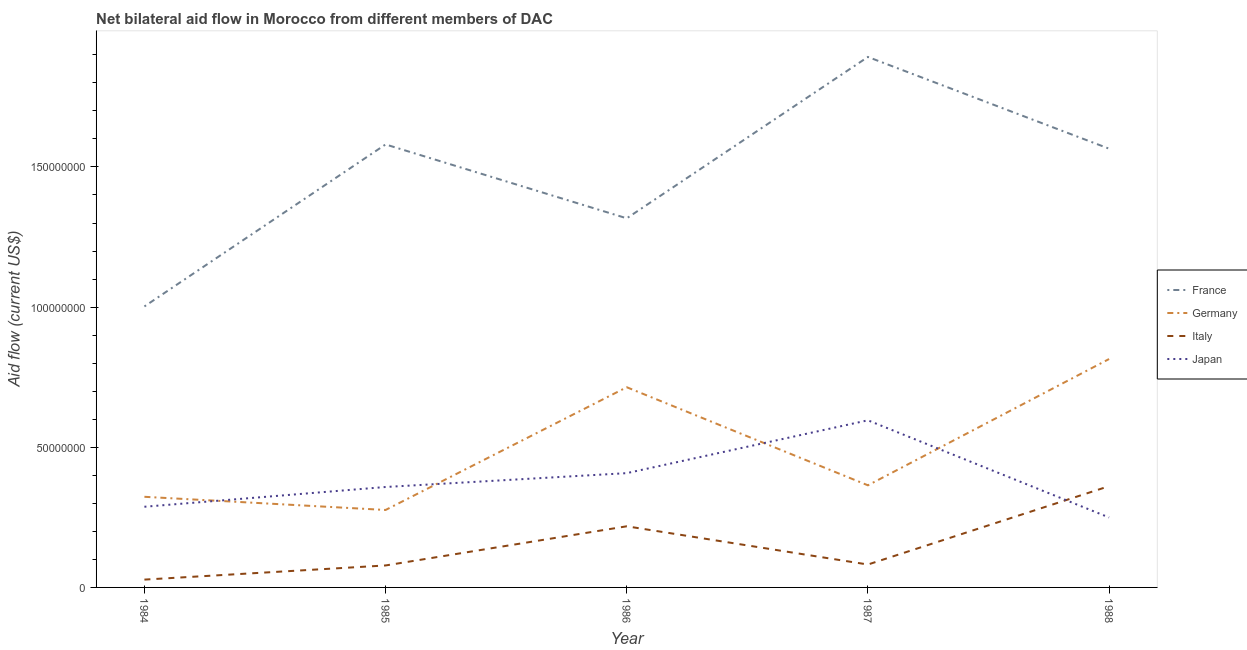Does the line corresponding to amount of aid given by germany intersect with the line corresponding to amount of aid given by italy?
Keep it short and to the point. No. What is the amount of aid given by france in 1986?
Offer a very short reply. 1.32e+08. Across all years, what is the maximum amount of aid given by japan?
Ensure brevity in your answer.  5.96e+07. Across all years, what is the minimum amount of aid given by japan?
Provide a short and direct response. 2.50e+07. In which year was the amount of aid given by germany minimum?
Give a very brief answer. 1985. What is the total amount of aid given by germany in the graph?
Offer a terse response. 2.49e+08. What is the difference between the amount of aid given by france in 1986 and that in 1988?
Offer a terse response. -2.48e+07. What is the difference between the amount of aid given by italy in 1988 and the amount of aid given by germany in 1985?
Your answer should be very brief. 8.50e+06. What is the average amount of aid given by germany per year?
Offer a very short reply. 4.99e+07. In the year 1987, what is the difference between the amount of aid given by france and amount of aid given by germany?
Offer a very short reply. 1.53e+08. What is the ratio of the amount of aid given by germany in 1984 to that in 1986?
Your response must be concise. 0.45. Is the amount of aid given by germany in 1987 less than that in 1988?
Offer a very short reply. Yes. Is the difference between the amount of aid given by france in 1984 and 1986 greater than the difference between the amount of aid given by japan in 1984 and 1986?
Give a very brief answer. No. What is the difference between the highest and the second highest amount of aid given by france?
Give a very brief answer. 3.12e+07. What is the difference between the highest and the lowest amount of aid given by france?
Make the answer very short. 8.90e+07. In how many years, is the amount of aid given by japan greater than the average amount of aid given by japan taken over all years?
Offer a terse response. 2. Is the sum of the amount of aid given by france in 1984 and 1986 greater than the maximum amount of aid given by italy across all years?
Offer a very short reply. Yes. Is it the case that in every year, the sum of the amount of aid given by italy and amount of aid given by japan is greater than the sum of amount of aid given by germany and amount of aid given by france?
Offer a terse response. No. Does the amount of aid given by italy monotonically increase over the years?
Offer a very short reply. No. Is the amount of aid given by japan strictly less than the amount of aid given by france over the years?
Offer a very short reply. Yes. Are the values on the major ticks of Y-axis written in scientific E-notation?
Keep it short and to the point. No. Does the graph contain any zero values?
Give a very brief answer. No. Does the graph contain grids?
Provide a short and direct response. No. How many legend labels are there?
Offer a very short reply. 4. What is the title of the graph?
Your answer should be compact. Net bilateral aid flow in Morocco from different members of DAC. Does "Primary schools" appear as one of the legend labels in the graph?
Give a very brief answer. No. What is the label or title of the Y-axis?
Make the answer very short. Aid flow (current US$). What is the Aid flow (current US$) of France in 1984?
Provide a short and direct response. 1.00e+08. What is the Aid flow (current US$) of Germany in 1984?
Your answer should be very brief. 3.23e+07. What is the Aid flow (current US$) of Italy in 1984?
Give a very brief answer. 2.79e+06. What is the Aid flow (current US$) of Japan in 1984?
Offer a terse response. 2.88e+07. What is the Aid flow (current US$) of France in 1985?
Your answer should be very brief. 1.58e+08. What is the Aid flow (current US$) in Germany in 1985?
Your answer should be very brief. 2.76e+07. What is the Aid flow (current US$) of Italy in 1985?
Make the answer very short. 7.84e+06. What is the Aid flow (current US$) in Japan in 1985?
Offer a very short reply. 3.58e+07. What is the Aid flow (current US$) in France in 1986?
Keep it short and to the point. 1.32e+08. What is the Aid flow (current US$) in Germany in 1986?
Your answer should be compact. 7.14e+07. What is the Aid flow (current US$) of Italy in 1986?
Your answer should be compact. 2.18e+07. What is the Aid flow (current US$) of Japan in 1986?
Your answer should be very brief. 4.08e+07. What is the Aid flow (current US$) of France in 1987?
Your response must be concise. 1.89e+08. What is the Aid flow (current US$) in Germany in 1987?
Ensure brevity in your answer.  3.64e+07. What is the Aid flow (current US$) of Italy in 1987?
Give a very brief answer. 8.17e+06. What is the Aid flow (current US$) in Japan in 1987?
Make the answer very short. 5.96e+07. What is the Aid flow (current US$) in France in 1988?
Offer a terse response. 1.57e+08. What is the Aid flow (current US$) in Germany in 1988?
Make the answer very short. 8.15e+07. What is the Aid flow (current US$) in Italy in 1988?
Provide a short and direct response. 3.61e+07. What is the Aid flow (current US$) of Japan in 1988?
Your response must be concise. 2.50e+07. Across all years, what is the maximum Aid flow (current US$) of France?
Ensure brevity in your answer.  1.89e+08. Across all years, what is the maximum Aid flow (current US$) in Germany?
Your answer should be very brief. 8.15e+07. Across all years, what is the maximum Aid flow (current US$) in Italy?
Your answer should be compact. 3.61e+07. Across all years, what is the maximum Aid flow (current US$) of Japan?
Your answer should be compact. 5.96e+07. Across all years, what is the minimum Aid flow (current US$) of France?
Provide a short and direct response. 1.00e+08. Across all years, what is the minimum Aid flow (current US$) in Germany?
Provide a short and direct response. 2.76e+07. Across all years, what is the minimum Aid flow (current US$) in Italy?
Give a very brief answer. 2.79e+06. Across all years, what is the minimum Aid flow (current US$) of Japan?
Provide a short and direct response. 2.50e+07. What is the total Aid flow (current US$) in France in the graph?
Keep it short and to the point. 7.36e+08. What is the total Aid flow (current US$) of Germany in the graph?
Offer a terse response. 2.49e+08. What is the total Aid flow (current US$) of Italy in the graph?
Keep it short and to the point. 7.67e+07. What is the total Aid flow (current US$) of Japan in the graph?
Offer a very short reply. 1.90e+08. What is the difference between the Aid flow (current US$) in France in 1984 and that in 1985?
Ensure brevity in your answer.  -5.78e+07. What is the difference between the Aid flow (current US$) of Germany in 1984 and that in 1985?
Ensure brevity in your answer.  4.70e+06. What is the difference between the Aid flow (current US$) in Italy in 1984 and that in 1985?
Your answer should be very brief. -5.05e+06. What is the difference between the Aid flow (current US$) in Japan in 1984 and that in 1985?
Keep it short and to the point. -7.05e+06. What is the difference between the Aid flow (current US$) of France in 1984 and that in 1986?
Keep it short and to the point. -3.14e+07. What is the difference between the Aid flow (current US$) of Germany in 1984 and that in 1986?
Keep it short and to the point. -3.91e+07. What is the difference between the Aid flow (current US$) of Italy in 1984 and that in 1986?
Your response must be concise. -1.90e+07. What is the difference between the Aid flow (current US$) of Japan in 1984 and that in 1986?
Offer a very short reply. -1.20e+07. What is the difference between the Aid flow (current US$) in France in 1984 and that in 1987?
Your answer should be very brief. -8.90e+07. What is the difference between the Aid flow (current US$) of Germany in 1984 and that in 1987?
Your answer should be very brief. -4.10e+06. What is the difference between the Aid flow (current US$) of Italy in 1984 and that in 1987?
Ensure brevity in your answer.  -5.38e+06. What is the difference between the Aid flow (current US$) of Japan in 1984 and that in 1987?
Offer a very short reply. -3.08e+07. What is the difference between the Aid flow (current US$) of France in 1984 and that in 1988?
Your answer should be very brief. -5.63e+07. What is the difference between the Aid flow (current US$) of Germany in 1984 and that in 1988?
Make the answer very short. -4.92e+07. What is the difference between the Aid flow (current US$) in Italy in 1984 and that in 1988?
Your response must be concise. -3.33e+07. What is the difference between the Aid flow (current US$) of Japan in 1984 and that in 1988?
Provide a short and direct response. 3.83e+06. What is the difference between the Aid flow (current US$) of France in 1985 and that in 1986?
Make the answer very short. 2.64e+07. What is the difference between the Aid flow (current US$) in Germany in 1985 and that in 1986?
Keep it short and to the point. -4.38e+07. What is the difference between the Aid flow (current US$) of Italy in 1985 and that in 1986?
Ensure brevity in your answer.  -1.40e+07. What is the difference between the Aid flow (current US$) in Japan in 1985 and that in 1986?
Ensure brevity in your answer.  -4.94e+06. What is the difference between the Aid flow (current US$) of France in 1985 and that in 1987?
Offer a terse response. -3.12e+07. What is the difference between the Aid flow (current US$) in Germany in 1985 and that in 1987?
Your answer should be very brief. -8.80e+06. What is the difference between the Aid flow (current US$) in Italy in 1985 and that in 1987?
Offer a terse response. -3.30e+05. What is the difference between the Aid flow (current US$) of Japan in 1985 and that in 1987?
Your answer should be compact. -2.38e+07. What is the difference between the Aid flow (current US$) in France in 1985 and that in 1988?
Provide a succinct answer. 1.51e+06. What is the difference between the Aid flow (current US$) in Germany in 1985 and that in 1988?
Keep it short and to the point. -5.38e+07. What is the difference between the Aid flow (current US$) of Italy in 1985 and that in 1988?
Give a very brief answer. -2.83e+07. What is the difference between the Aid flow (current US$) of Japan in 1985 and that in 1988?
Provide a succinct answer. 1.09e+07. What is the difference between the Aid flow (current US$) in France in 1986 and that in 1987?
Your answer should be compact. -5.76e+07. What is the difference between the Aid flow (current US$) of Germany in 1986 and that in 1987?
Give a very brief answer. 3.50e+07. What is the difference between the Aid flow (current US$) in Italy in 1986 and that in 1987?
Your answer should be very brief. 1.36e+07. What is the difference between the Aid flow (current US$) in Japan in 1986 and that in 1987?
Your answer should be very brief. -1.88e+07. What is the difference between the Aid flow (current US$) in France in 1986 and that in 1988?
Your answer should be compact. -2.48e+07. What is the difference between the Aid flow (current US$) in Germany in 1986 and that in 1988?
Give a very brief answer. -1.01e+07. What is the difference between the Aid flow (current US$) in Italy in 1986 and that in 1988?
Offer a very short reply. -1.43e+07. What is the difference between the Aid flow (current US$) in Japan in 1986 and that in 1988?
Your answer should be compact. 1.58e+07. What is the difference between the Aid flow (current US$) in France in 1987 and that in 1988?
Make the answer very short. 3.27e+07. What is the difference between the Aid flow (current US$) of Germany in 1987 and that in 1988?
Give a very brief answer. -4.50e+07. What is the difference between the Aid flow (current US$) of Italy in 1987 and that in 1988?
Give a very brief answer. -2.80e+07. What is the difference between the Aid flow (current US$) of Japan in 1987 and that in 1988?
Your answer should be compact. 3.47e+07. What is the difference between the Aid flow (current US$) in France in 1984 and the Aid flow (current US$) in Germany in 1985?
Give a very brief answer. 7.26e+07. What is the difference between the Aid flow (current US$) of France in 1984 and the Aid flow (current US$) of Italy in 1985?
Your response must be concise. 9.24e+07. What is the difference between the Aid flow (current US$) of France in 1984 and the Aid flow (current US$) of Japan in 1985?
Your response must be concise. 6.44e+07. What is the difference between the Aid flow (current US$) in Germany in 1984 and the Aid flow (current US$) in Italy in 1985?
Provide a short and direct response. 2.45e+07. What is the difference between the Aid flow (current US$) of Germany in 1984 and the Aid flow (current US$) of Japan in 1985?
Offer a very short reply. -3.50e+06. What is the difference between the Aid flow (current US$) of Italy in 1984 and the Aid flow (current US$) of Japan in 1985?
Ensure brevity in your answer.  -3.30e+07. What is the difference between the Aid flow (current US$) of France in 1984 and the Aid flow (current US$) of Germany in 1986?
Provide a succinct answer. 2.88e+07. What is the difference between the Aid flow (current US$) in France in 1984 and the Aid flow (current US$) in Italy in 1986?
Offer a terse response. 7.84e+07. What is the difference between the Aid flow (current US$) in France in 1984 and the Aid flow (current US$) in Japan in 1986?
Your answer should be very brief. 5.95e+07. What is the difference between the Aid flow (current US$) in Germany in 1984 and the Aid flow (current US$) in Italy in 1986?
Ensure brevity in your answer.  1.05e+07. What is the difference between the Aid flow (current US$) in Germany in 1984 and the Aid flow (current US$) in Japan in 1986?
Provide a short and direct response. -8.44e+06. What is the difference between the Aid flow (current US$) of Italy in 1984 and the Aid flow (current US$) of Japan in 1986?
Make the answer very short. -3.80e+07. What is the difference between the Aid flow (current US$) of France in 1984 and the Aid flow (current US$) of Germany in 1987?
Ensure brevity in your answer.  6.38e+07. What is the difference between the Aid flow (current US$) of France in 1984 and the Aid flow (current US$) of Italy in 1987?
Your response must be concise. 9.21e+07. What is the difference between the Aid flow (current US$) of France in 1984 and the Aid flow (current US$) of Japan in 1987?
Provide a short and direct response. 4.06e+07. What is the difference between the Aid flow (current US$) in Germany in 1984 and the Aid flow (current US$) in Italy in 1987?
Give a very brief answer. 2.42e+07. What is the difference between the Aid flow (current US$) in Germany in 1984 and the Aid flow (current US$) in Japan in 1987?
Your answer should be compact. -2.73e+07. What is the difference between the Aid flow (current US$) in Italy in 1984 and the Aid flow (current US$) in Japan in 1987?
Ensure brevity in your answer.  -5.68e+07. What is the difference between the Aid flow (current US$) of France in 1984 and the Aid flow (current US$) of Germany in 1988?
Make the answer very short. 1.88e+07. What is the difference between the Aid flow (current US$) of France in 1984 and the Aid flow (current US$) of Italy in 1988?
Your answer should be compact. 6.41e+07. What is the difference between the Aid flow (current US$) of France in 1984 and the Aid flow (current US$) of Japan in 1988?
Keep it short and to the point. 7.53e+07. What is the difference between the Aid flow (current US$) in Germany in 1984 and the Aid flow (current US$) in Italy in 1988?
Give a very brief answer. -3.80e+06. What is the difference between the Aid flow (current US$) of Germany in 1984 and the Aid flow (current US$) of Japan in 1988?
Offer a terse response. 7.38e+06. What is the difference between the Aid flow (current US$) of Italy in 1984 and the Aid flow (current US$) of Japan in 1988?
Your answer should be very brief. -2.22e+07. What is the difference between the Aid flow (current US$) of France in 1985 and the Aid flow (current US$) of Germany in 1986?
Ensure brevity in your answer.  8.66e+07. What is the difference between the Aid flow (current US$) in France in 1985 and the Aid flow (current US$) in Italy in 1986?
Provide a short and direct response. 1.36e+08. What is the difference between the Aid flow (current US$) of France in 1985 and the Aid flow (current US$) of Japan in 1986?
Offer a very short reply. 1.17e+08. What is the difference between the Aid flow (current US$) in Germany in 1985 and the Aid flow (current US$) in Italy in 1986?
Keep it short and to the point. 5.82e+06. What is the difference between the Aid flow (current US$) of Germany in 1985 and the Aid flow (current US$) of Japan in 1986?
Your answer should be very brief. -1.31e+07. What is the difference between the Aid flow (current US$) of Italy in 1985 and the Aid flow (current US$) of Japan in 1986?
Offer a terse response. -3.29e+07. What is the difference between the Aid flow (current US$) in France in 1985 and the Aid flow (current US$) in Germany in 1987?
Offer a very short reply. 1.22e+08. What is the difference between the Aid flow (current US$) of France in 1985 and the Aid flow (current US$) of Italy in 1987?
Make the answer very short. 1.50e+08. What is the difference between the Aid flow (current US$) in France in 1985 and the Aid flow (current US$) in Japan in 1987?
Your answer should be very brief. 9.84e+07. What is the difference between the Aid flow (current US$) in Germany in 1985 and the Aid flow (current US$) in Italy in 1987?
Your answer should be compact. 1.95e+07. What is the difference between the Aid flow (current US$) of Germany in 1985 and the Aid flow (current US$) of Japan in 1987?
Keep it short and to the point. -3.20e+07. What is the difference between the Aid flow (current US$) in Italy in 1985 and the Aid flow (current US$) in Japan in 1987?
Ensure brevity in your answer.  -5.18e+07. What is the difference between the Aid flow (current US$) in France in 1985 and the Aid flow (current US$) in Germany in 1988?
Provide a short and direct response. 7.66e+07. What is the difference between the Aid flow (current US$) of France in 1985 and the Aid flow (current US$) of Italy in 1988?
Provide a short and direct response. 1.22e+08. What is the difference between the Aid flow (current US$) of France in 1985 and the Aid flow (current US$) of Japan in 1988?
Your answer should be very brief. 1.33e+08. What is the difference between the Aid flow (current US$) of Germany in 1985 and the Aid flow (current US$) of Italy in 1988?
Keep it short and to the point. -8.50e+06. What is the difference between the Aid flow (current US$) of Germany in 1985 and the Aid flow (current US$) of Japan in 1988?
Make the answer very short. 2.68e+06. What is the difference between the Aid flow (current US$) of Italy in 1985 and the Aid flow (current US$) of Japan in 1988?
Your answer should be very brief. -1.71e+07. What is the difference between the Aid flow (current US$) in France in 1986 and the Aid flow (current US$) in Germany in 1987?
Make the answer very short. 9.52e+07. What is the difference between the Aid flow (current US$) in France in 1986 and the Aid flow (current US$) in Italy in 1987?
Ensure brevity in your answer.  1.24e+08. What is the difference between the Aid flow (current US$) in France in 1986 and the Aid flow (current US$) in Japan in 1987?
Your answer should be compact. 7.21e+07. What is the difference between the Aid flow (current US$) of Germany in 1986 and the Aid flow (current US$) of Italy in 1987?
Offer a very short reply. 6.32e+07. What is the difference between the Aid flow (current US$) of Germany in 1986 and the Aid flow (current US$) of Japan in 1987?
Provide a succinct answer. 1.18e+07. What is the difference between the Aid flow (current US$) in Italy in 1986 and the Aid flow (current US$) in Japan in 1987?
Offer a terse response. -3.78e+07. What is the difference between the Aid flow (current US$) in France in 1986 and the Aid flow (current US$) in Germany in 1988?
Offer a very short reply. 5.02e+07. What is the difference between the Aid flow (current US$) of France in 1986 and the Aid flow (current US$) of Italy in 1988?
Your answer should be compact. 9.56e+07. What is the difference between the Aid flow (current US$) of France in 1986 and the Aid flow (current US$) of Japan in 1988?
Provide a short and direct response. 1.07e+08. What is the difference between the Aid flow (current US$) in Germany in 1986 and the Aid flow (current US$) in Italy in 1988?
Offer a very short reply. 3.53e+07. What is the difference between the Aid flow (current US$) of Germany in 1986 and the Aid flow (current US$) of Japan in 1988?
Provide a succinct answer. 4.65e+07. What is the difference between the Aid flow (current US$) in Italy in 1986 and the Aid flow (current US$) in Japan in 1988?
Keep it short and to the point. -3.14e+06. What is the difference between the Aid flow (current US$) of France in 1987 and the Aid flow (current US$) of Germany in 1988?
Make the answer very short. 1.08e+08. What is the difference between the Aid flow (current US$) in France in 1987 and the Aid flow (current US$) in Italy in 1988?
Offer a very short reply. 1.53e+08. What is the difference between the Aid flow (current US$) of France in 1987 and the Aid flow (current US$) of Japan in 1988?
Your answer should be compact. 1.64e+08. What is the difference between the Aid flow (current US$) of Germany in 1987 and the Aid flow (current US$) of Japan in 1988?
Your answer should be compact. 1.15e+07. What is the difference between the Aid flow (current US$) of Italy in 1987 and the Aid flow (current US$) of Japan in 1988?
Provide a succinct answer. -1.68e+07. What is the average Aid flow (current US$) in France per year?
Your answer should be compact. 1.47e+08. What is the average Aid flow (current US$) of Germany per year?
Your answer should be compact. 4.99e+07. What is the average Aid flow (current US$) in Italy per year?
Offer a very short reply. 1.53e+07. What is the average Aid flow (current US$) in Japan per year?
Provide a succinct answer. 3.80e+07. In the year 1984, what is the difference between the Aid flow (current US$) in France and Aid flow (current US$) in Germany?
Ensure brevity in your answer.  6.79e+07. In the year 1984, what is the difference between the Aid flow (current US$) in France and Aid flow (current US$) in Italy?
Keep it short and to the point. 9.74e+07. In the year 1984, what is the difference between the Aid flow (current US$) in France and Aid flow (current US$) in Japan?
Ensure brevity in your answer.  7.15e+07. In the year 1984, what is the difference between the Aid flow (current US$) of Germany and Aid flow (current US$) of Italy?
Make the answer very short. 2.95e+07. In the year 1984, what is the difference between the Aid flow (current US$) in Germany and Aid flow (current US$) in Japan?
Your answer should be very brief. 3.55e+06. In the year 1984, what is the difference between the Aid flow (current US$) in Italy and Aid flow (current US$) in Japan?
Make the answer very short. -2.60e+07. In the year 1985, what is the difference between the Aid flow (current US$) of France and Aid flow (current US$) of Germany?
Keep it short and to the point. 1.30e+08. In the year 1985, what is the difference between the Aid flow (current US$) of France and Aid flow (current US$) of Italy?
Your response must be concise. 1.50e+08. In the year 1985, what is the difference between the Aid flow (current US$) of France and Aid flow (current US$) of Japan?
Make the answer very short. 1.22e+08. In the year 1985, what is the difference between the Aid flow (current US$) in Germany and Aid flow (current US$) in Italy?
Your response must be concise. 1.98e+07. In the year 1985, what is the difference between the Aid flow (current US$) in Germany and Aid flow (current US$) in Japan?
Offer a very short reply. -8.20e+06. In the year 1985, what is the difference between the Aid flow (current US$) in Italy and Aid flow (current US$) in Japan?
Give a very brief answer. -2.80e+07. In the year 1986, what is the difference between the Aid flow (current US$) in France and Aid flow (current US$) in Germany?
Offer a terse response. 6.03e+07. In the year 1986, what is the difference between the Aid flow (current US$) of France and Aid flow (current US$) of Italy?
Offer a terse response. 1.10e+08. In the year 1986, what is the difference between the Aid flow (current US$) in France and Aid flow (current US$) in Japan?
Offer a terse response. 9.09e+07. In the year 1986, what is the difference between the Aid flow (current US$) in Germany and Aid flow (current US$) in Italy?
Give a very brief answer. 4.96e+07. In the year 1986, what is the difference between the Aid flow (current US$) of Germany and Aid flow (current US$) of Japan?
Give a very brief answer. 3.06e+07. In the year 1986, what is the difference between the Aid flow (current US$) of Italy and Aid flow (current US$) of Japan?
Your answer should be compact. -1.90e+07. In the year 1987, what is the difference between the Aid flow (current US$) in France and Aid flow (current US$) in Germany?
Your answer should be very brief. 1.53e+08. In the year 1987, what is the difference between the Aid flow (current US$) of France and Aid flow (current US$) of Italy?
Make the answer very short. 1.81e+08. In the year 1987, what is the difference between the Aid flow (current US$) of France and Aid flow (current US$) of Japan?
Provide a short and direct response. 1.30e+08. In the year 1987, what is the difference between the Aid flow (current US$) of Germany and Aid flow (current US$) of Italy?
Provide a short and direct response. 2.83e+07. In the year 1987, what is the difference between the Aid flow (current US$) in Germany and Aid flow (current US$) in Japan?
Provide a short and direct response. -2.32e+07. In the year 1987, what is the difference between the Aid flow (current US$) of Italy and Aid flow (current US$) of Japan?
Ensure brevity in your answer.  -5.14e+07. In the year 1988, what is the difference between the Aid flow (current US$) of France and Aid flow (current US$) of Germany?
Your response must be concise. 7.50e+07. In the year 1988, what is the difference between the Aid flow (current US$) in France and Aid flow (current US$) in Italy?
Your answer should be compact. 1.20e+08. In the year 1988, what is the difference between the Aid flow (current US$) in France and Aid flow (current US$) in Japan?
Make the answer very short. 1.32e+08. In the year 1988, what is the difference between the Aid flow (current US$) in Germany and Aid flow (current US$) in Italy?
Keep it short and to the point. 4.54e+07. In the year 1988, what is the difference between the Aid flow (current US$) in Germany and Aid flow (current US$) in Japan?
Your response must be concise. 5.65e+07. In the year 1988, what is the difference between the Aid flow (current US$) of Italy and Aid flow (current US$) of Japan?
Make the answer very short. 1.12e+07. What is the ratio of the Aid flow (current US$) in France in 1984 to that in 1985?
Provide a short and direct response. 0.63. What is the ratio of the Aid flow (current US$) in Germany in 1984 to that in 1985?
Keep it short and to the point. 1.17. What is the ratio of the Aid flow (current US$) of Italy in 1984 to that in 1985?
Make the answer very short. 0.36. What is the ratio of the Aid flow (current US$) in Japan in 1984 to that in 1985?
Your answer should be compact. 0.8. What is the ratio of the Aid flow (current US$) in France in 1984 to that in 1986?
Your answer should be very brief. 0.76. What is the ratio of the Aid flow (current US$) of Germany in 1984 to that in 1986?
Make the answer very short. 0.45. What is the ratio of the Aid flow (current US$) of Italy in 1984 to that in 1986?
Your response must be concise. 0.13. What is the ratio of the Aid flow (current US$) in Japan in 1984 to that in 1986?
Make the answer very short. 0.71. What is the ratio of the Aid flow (current US$) of France in 1984 to that in 1987?
Your response must be concise. 0.53. What is the ratio of the Aid flow (current US$) in Germany in 1984 to that in 1987?
Your response must be concise. 0.89. What is the ratio of the Aid flow (current US$) in Italy in 1984 to that in 1987?
Provide a succinct answer. 0.34. What is the ratio of the Aid flow (current US$) in Japan in 1984 to that in 1987?
Keep it short and to the point. 0.48. What is the ratio of the Aid flow (current US$) of France in 1984 to that in 1988?
Your answer should be very brief. 0.64. What is the ratio of the Aid flow (current US$) of Germany in 1984 to that in 1988?
Ensure brevity in your answer.  0.4. What is the ratio of the Aid flow (current US$) in Italy in 1984 to that in 1988?
Your response must be concise. 0.08. What is the ratio of the Aid flow (current US$) in Japan in 1984 to that in 1988?
Ensure brevity in your answer.  1.15. What is the ratio of the Aid flow (current US$) of France in 1985 to that in 1986?
Your answer should be very brief. 1.2. What is the ratio of the Aid flow (current US$) in Germany in 1985 to that in 1986?
Offer a terse response. 0.39. What is the ratio of the Aid flow (current US$) in Italy in 1985 to that in 1986?
Provide a succinct answer. 0.36. What is the ratio of the Aid flow (current US$) in Japan in 1985 to that in 1986?
Offer a terse response. 0.88. What is the ratio of the Aid flow (current US$) in France in 1985 to that in 1987?
Your answer should be very brief. 0.84. What is the ratio of the Aid flow (current US$) of Germany in 1985 to that in 1987?
Provide a succinct answer. 0.76. What is the ratio of the Aid flow (current US$) of Italy in 1985 to that in 1987?
Your answer should be compact. 0.96. What is the ratio of the Aid flow (current US$) of Japan in 1985 to that in 1987?
Ensure brevity in your answer.  0.6. What is the ratio of the Aid flow (current US$) of France in 1985 to that in 1988?
Provide a short and direct response. 1.01. What is the ratio of the Aid flow (current US$) of Germany in 1985 to that in 1988?
Ensure brevity in your answer.  0.34. What is the ratio of the Aid flow (current US$) of Italy in 1985 to that in 1988?
Provide a short and direct response. 0.22. What is the ratio of the Aid flow (current US$) of Japan in 1985 to that in 1988?
Make the answer very short. 1.44. What is the ratio of the Aid flow (current US$) of France in 1986 to that in 1987?
Offer a very short reply. 0.7. What is the ratio of the Aid flow (current US$) in Germany in 1986 to that in 1987?
Keep it short and to the point. 1.96. What is the ratio of the Aid flow (current US$) of Italy in 1986 to that in 1987?
Your answer should be very brief. 2.67. What is the ratio of the Aid flow (current US$) of Japan in 1986 to that in 1987?
Ensure brevity in your answer.  0.68. What is the ratio of the Aid flow (current US$) of France in 1986 to that in 1988?
Your answer should be compact. 0.84. What is the ratio of the Aid flow (current US$) in Germany in 1986 to that in 1988?
Your answer should be compact. 0.88. What is the ratio of the Aid flow (current US$) in Italy in 1986 to that in 1988?
Ensure brevity in your answer.  0.6. What is the ratio of the Aid flow (current US$) of Japan in 1986 to that in 1988?
Give a very brief answer. 1.63. What is the ratio of the Aid flow (current US$) in France in 1987 to that in 1988?
Provide a short and direct response. 1.21. What is the ratio of the Aid flow (current US$) in Germany in 1987 to that in 1988?
Your response must be concise. 0.45. What is the ratio of the Aid flow (current US$) in Italy in 1987 to that in 1988?
Provide a short and direct response. 0.23. What is the ratio of the Aid flow (current US$) of Japan in 1987 to that in 1988?
Your answer should be compact. 2.39. What is the difference between the highest and the second highest Aid flow (current US$) in France?
Your answer should be very brief. 3.12e+07. What is the difference between the highest and the second highest Aid flow (current US$) of Germany?
Offer a terse response. 1.01e+07. What is the difference between the highest and the second highest Aid flow (current US$) in Italy?
Offer a very short reply. 1.43e+07. What is the difference between the highest and the second highest Aid flow (current US$) of Japan?
Offer a terse response. 1.88e+07. What is the difference between the highest and the lowest Aid flow (current US$) in France?
Provide a succinct answer. 8.90e+07. What is the difference between the highest and the lowest Aid flow (current US$) in Germany?
Your answer should be very brief. 5.38e+07. What is the difference between the highest and the lowest Aid flow (current US$) in Italy?
Provide a succinct answer. 3.33e+07. What is the difference between the highest and the lowest Aid flow (current US$) of Japan?
Offer a very short reply. 3.47e+07. 